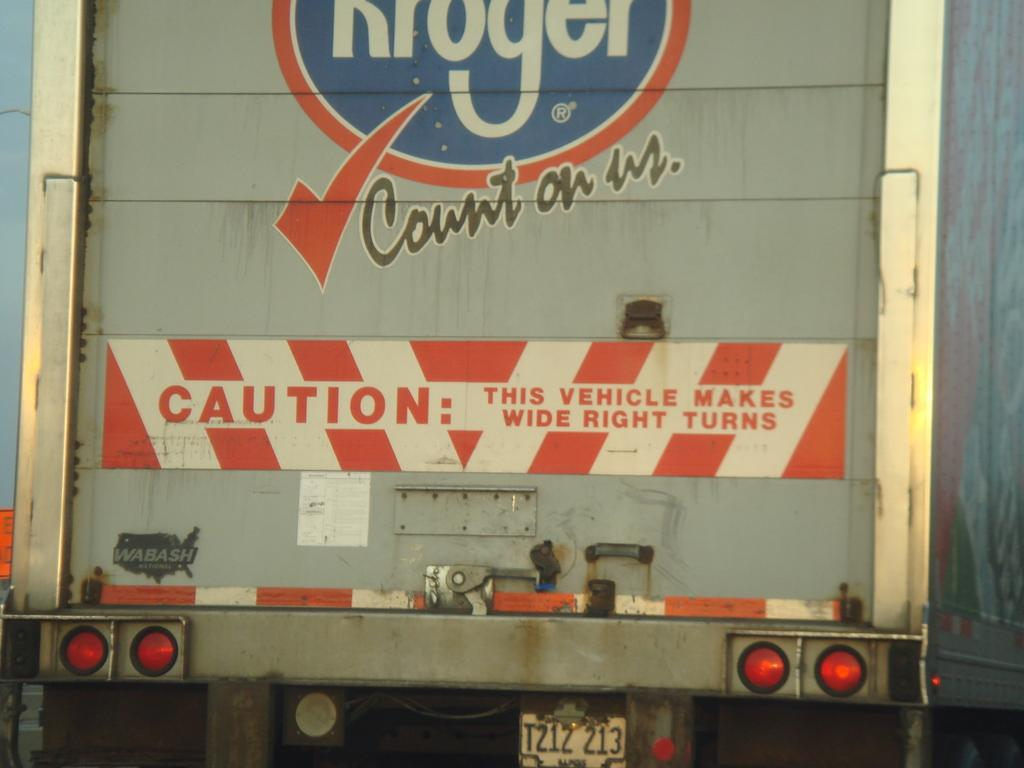What is the main subject of the image? The main subject of the image is a vehicle. What can be seen on the vehicle that helps with identification? The vehicle has a number plate. What features are present on the vehicle for visibility and safety? The vehicle has lights. What additional information is provided on the vehicle? There is writing on the vehicle. How many oranges are visible on the vehicle in the image? There are no oranges present on the vehicle in the image. What type of button can be seen on the vehicle in the image? There is no button visible on the vehicle in the image. 